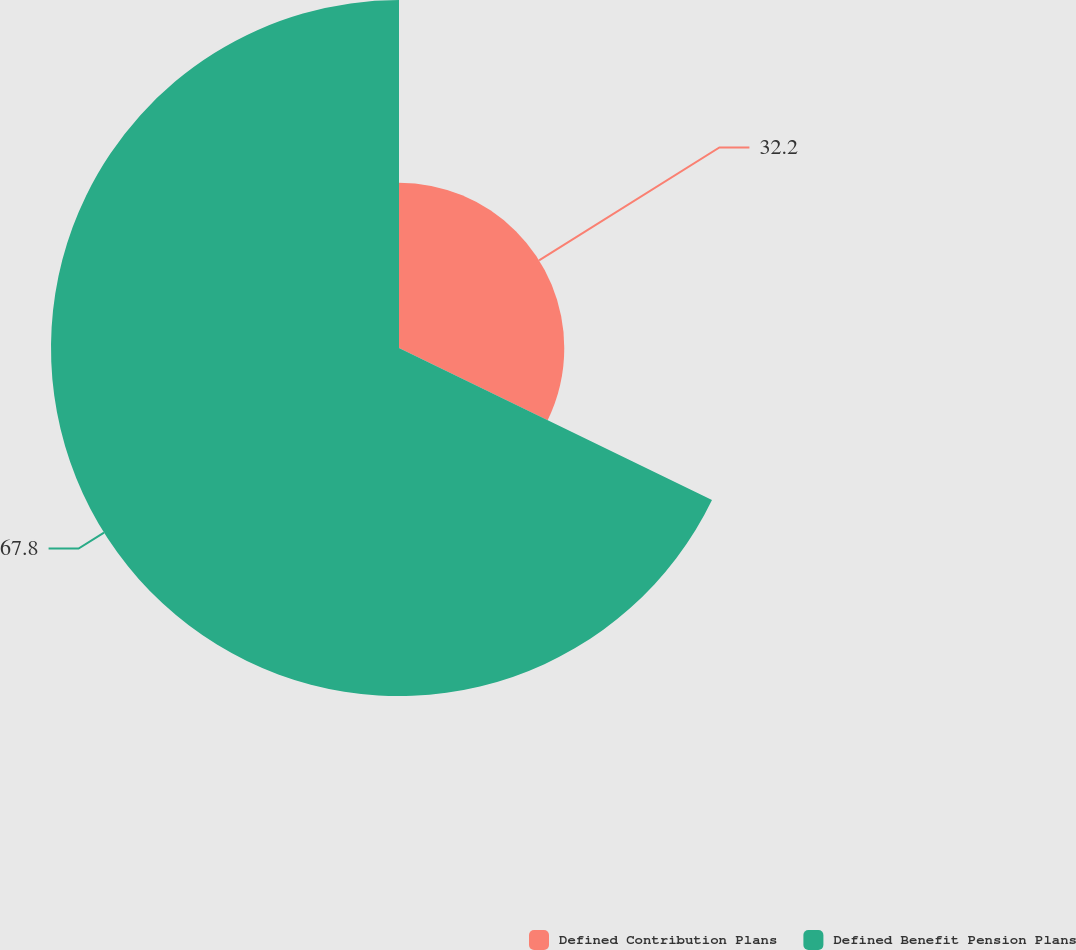<chart> <loc_0><loc_0><loc_500><loc_500><pie_chart><fcel>Defined Contribution Plans<fcel>Defined Benefit Pension Plans<nl><fcel>32.2%<fcel>67.8%<nl></chart> 